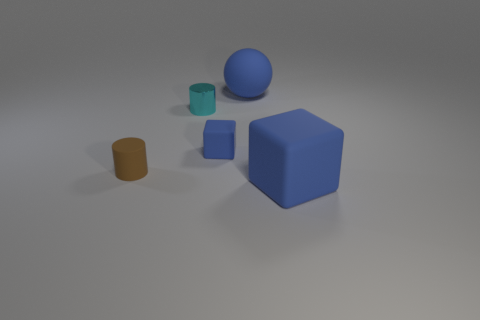Add 5 small blue cubes. How many objects exist? 10 Subtract 2 blocks. How many blocks are left? 0 Subtract all brown cylinders. How many cylinders are left? 1 Subtract all spheres. How many objects are left? 4 Subtract all green balls. Subtract all green blocks. How many balls are left? 1 Subtract all small matte things. Subtract all blue balls. How many objects are left? 2 Add 1 tiny blue rubber objects. How many tiny blue rubber objects are left? 2 Add 4 large rubber cubes. How many large rubber cubes exist? 5 Subtract 0 green balls. How many objects are left? 5 